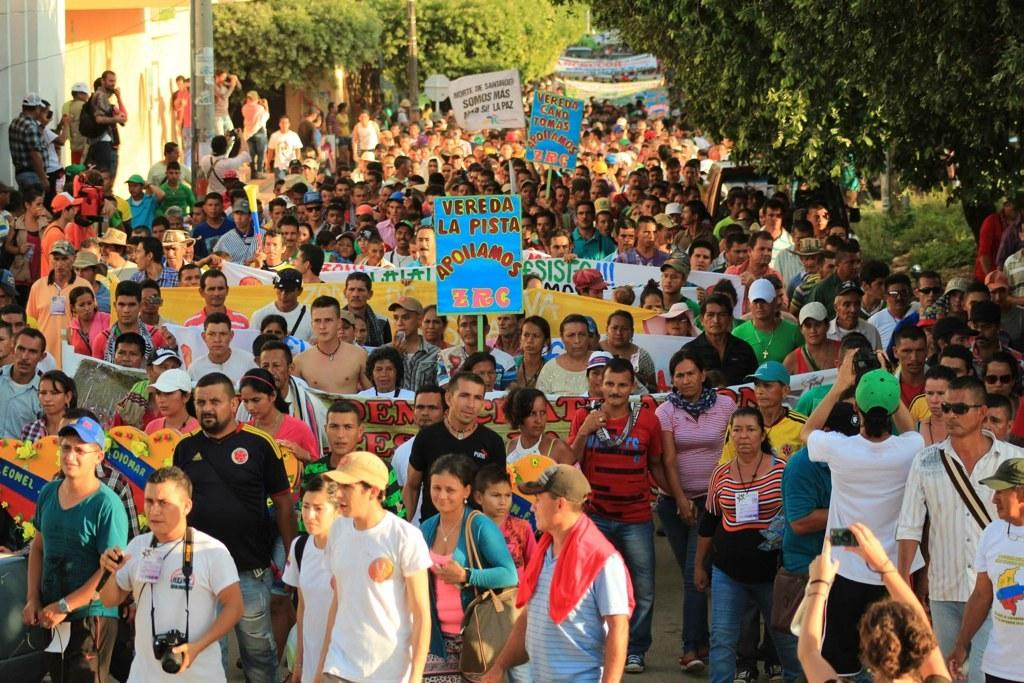What are the people in the image doing? The people in the image are standing and holding banners, cameras, and bags. What might the people be using the cameras for? The people might be using the cameras to take pictures or document the event. What can be seen in the background of the image? There are trees, buildings, and poles in the background of the image. What hobbies do the people's friends have in the image? There is no information about the people's friends or their hobbies in the image. 